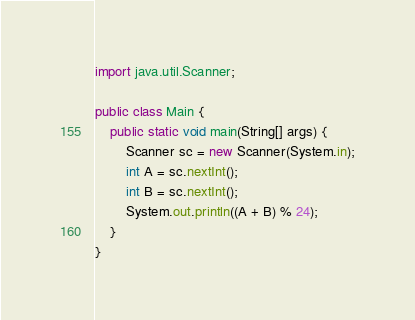Convert code to text. <code><loc_0><loc_0><loc_500><loc_500><_Java_>import java.util.Scanner;

public class Main {
	public static void main(String[] args) {
		Scanner sc = new Scanner(System.in);
		int A = sc.nextInt();
		int B = sc.nextInt();
		System.out.println((A + B) % 24);
	}
}
</code> 